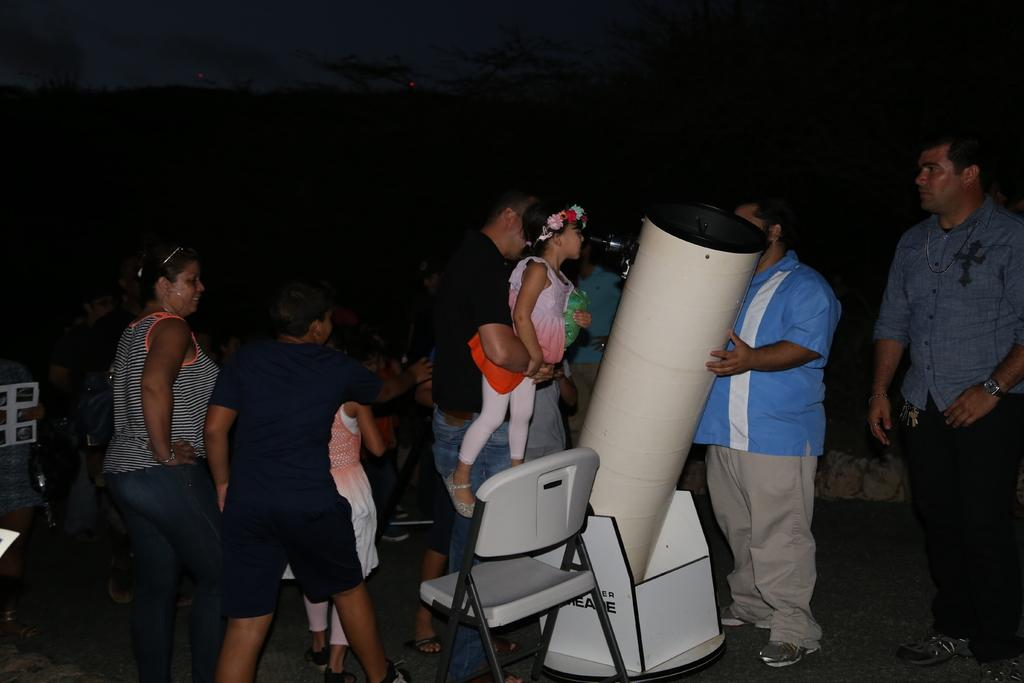What is happening in the image? There are people standing in the image. Can you describe any objects in the image? There is a chair in the image. What type of toothpaste is being used by the people in the image? There is no toothpaste present in the image, as it features people standing and a chair. 